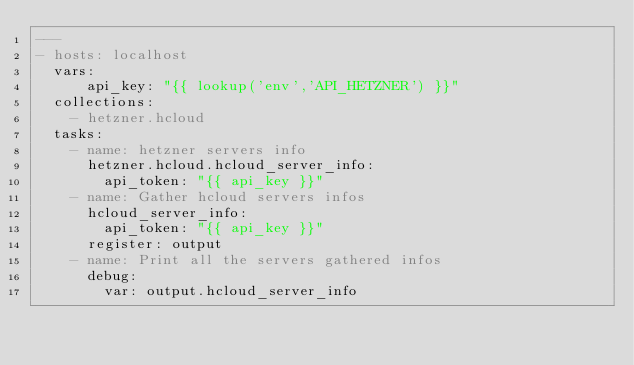<code> <loc_0><loc_0><loc_500><loc_500><_YAML_>---
- hosts: localhost
  vars:
      api_key: "{{ lookup('env','API_HETZNER') }}"
  collections:
    - hetzner.hcloud
  tasks:
    - name: hetzner servers info
      hetzner.hcloud.hcloud_server_info:
        api_token: "{{ api_key }}"
    - name: Gather hcloud servers infos
      hcloud_server_info:
        api_token: "{{ api_key }}"
      register: output
    - name: Print all the servers gathered infos
      debug:
        var: output.hcloud_server_info
</code> 